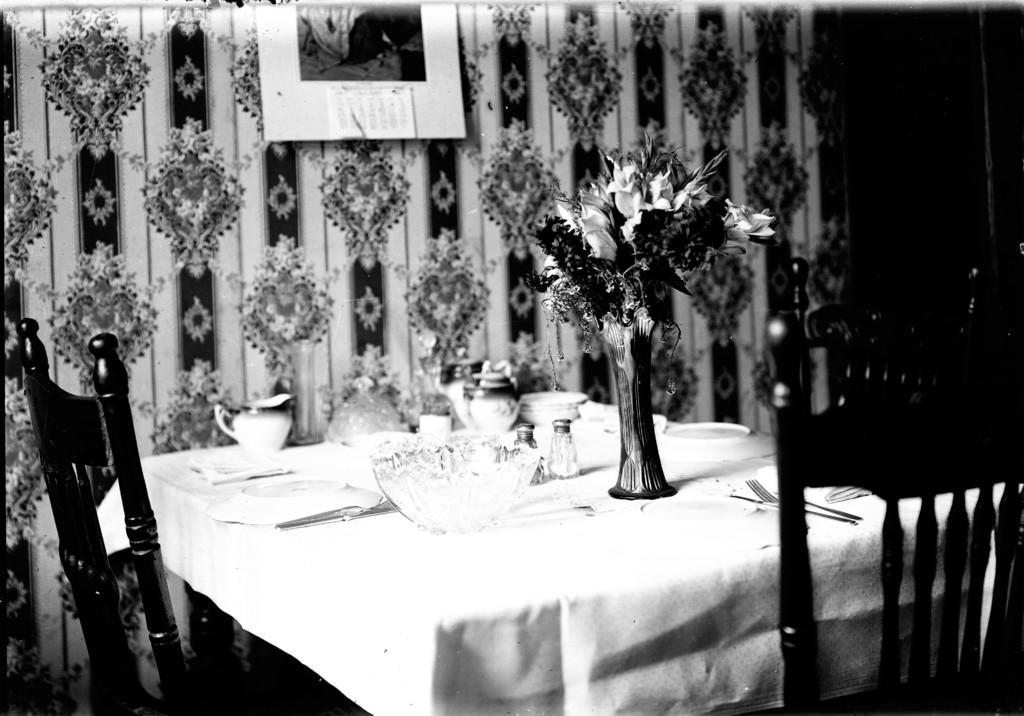How would you summarize this image in a sentence or two? In this image I can see few chairs and a table. On this table I can see few cups, few plates, few spoons, a bowl and a flower. On this wall I can see a poster. 